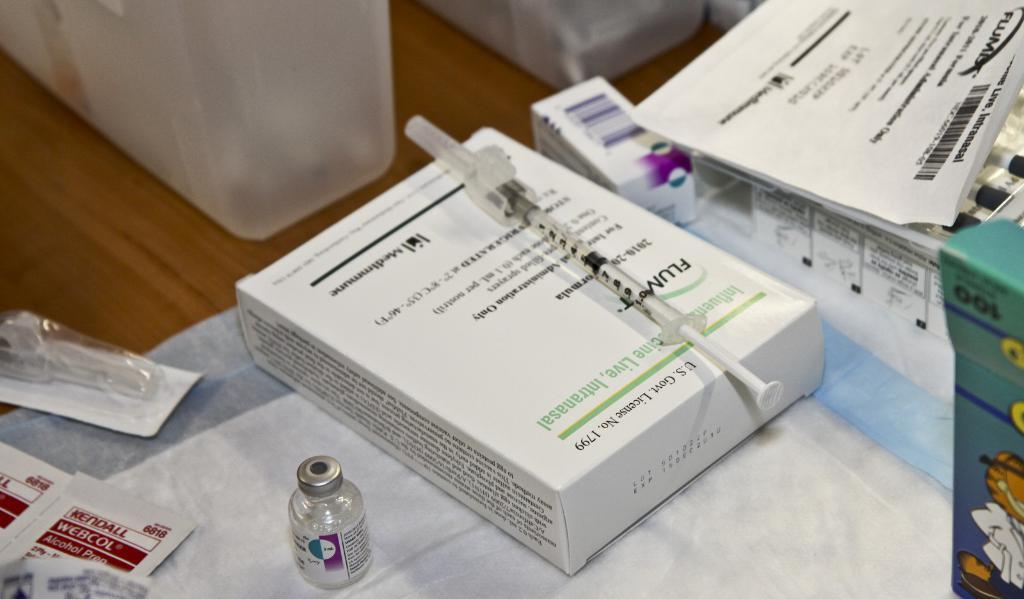<image>
Write a terse but informative summary of the picture. A box and a syringe and stated on the box is the U.S. Govt. License No. 1799. 